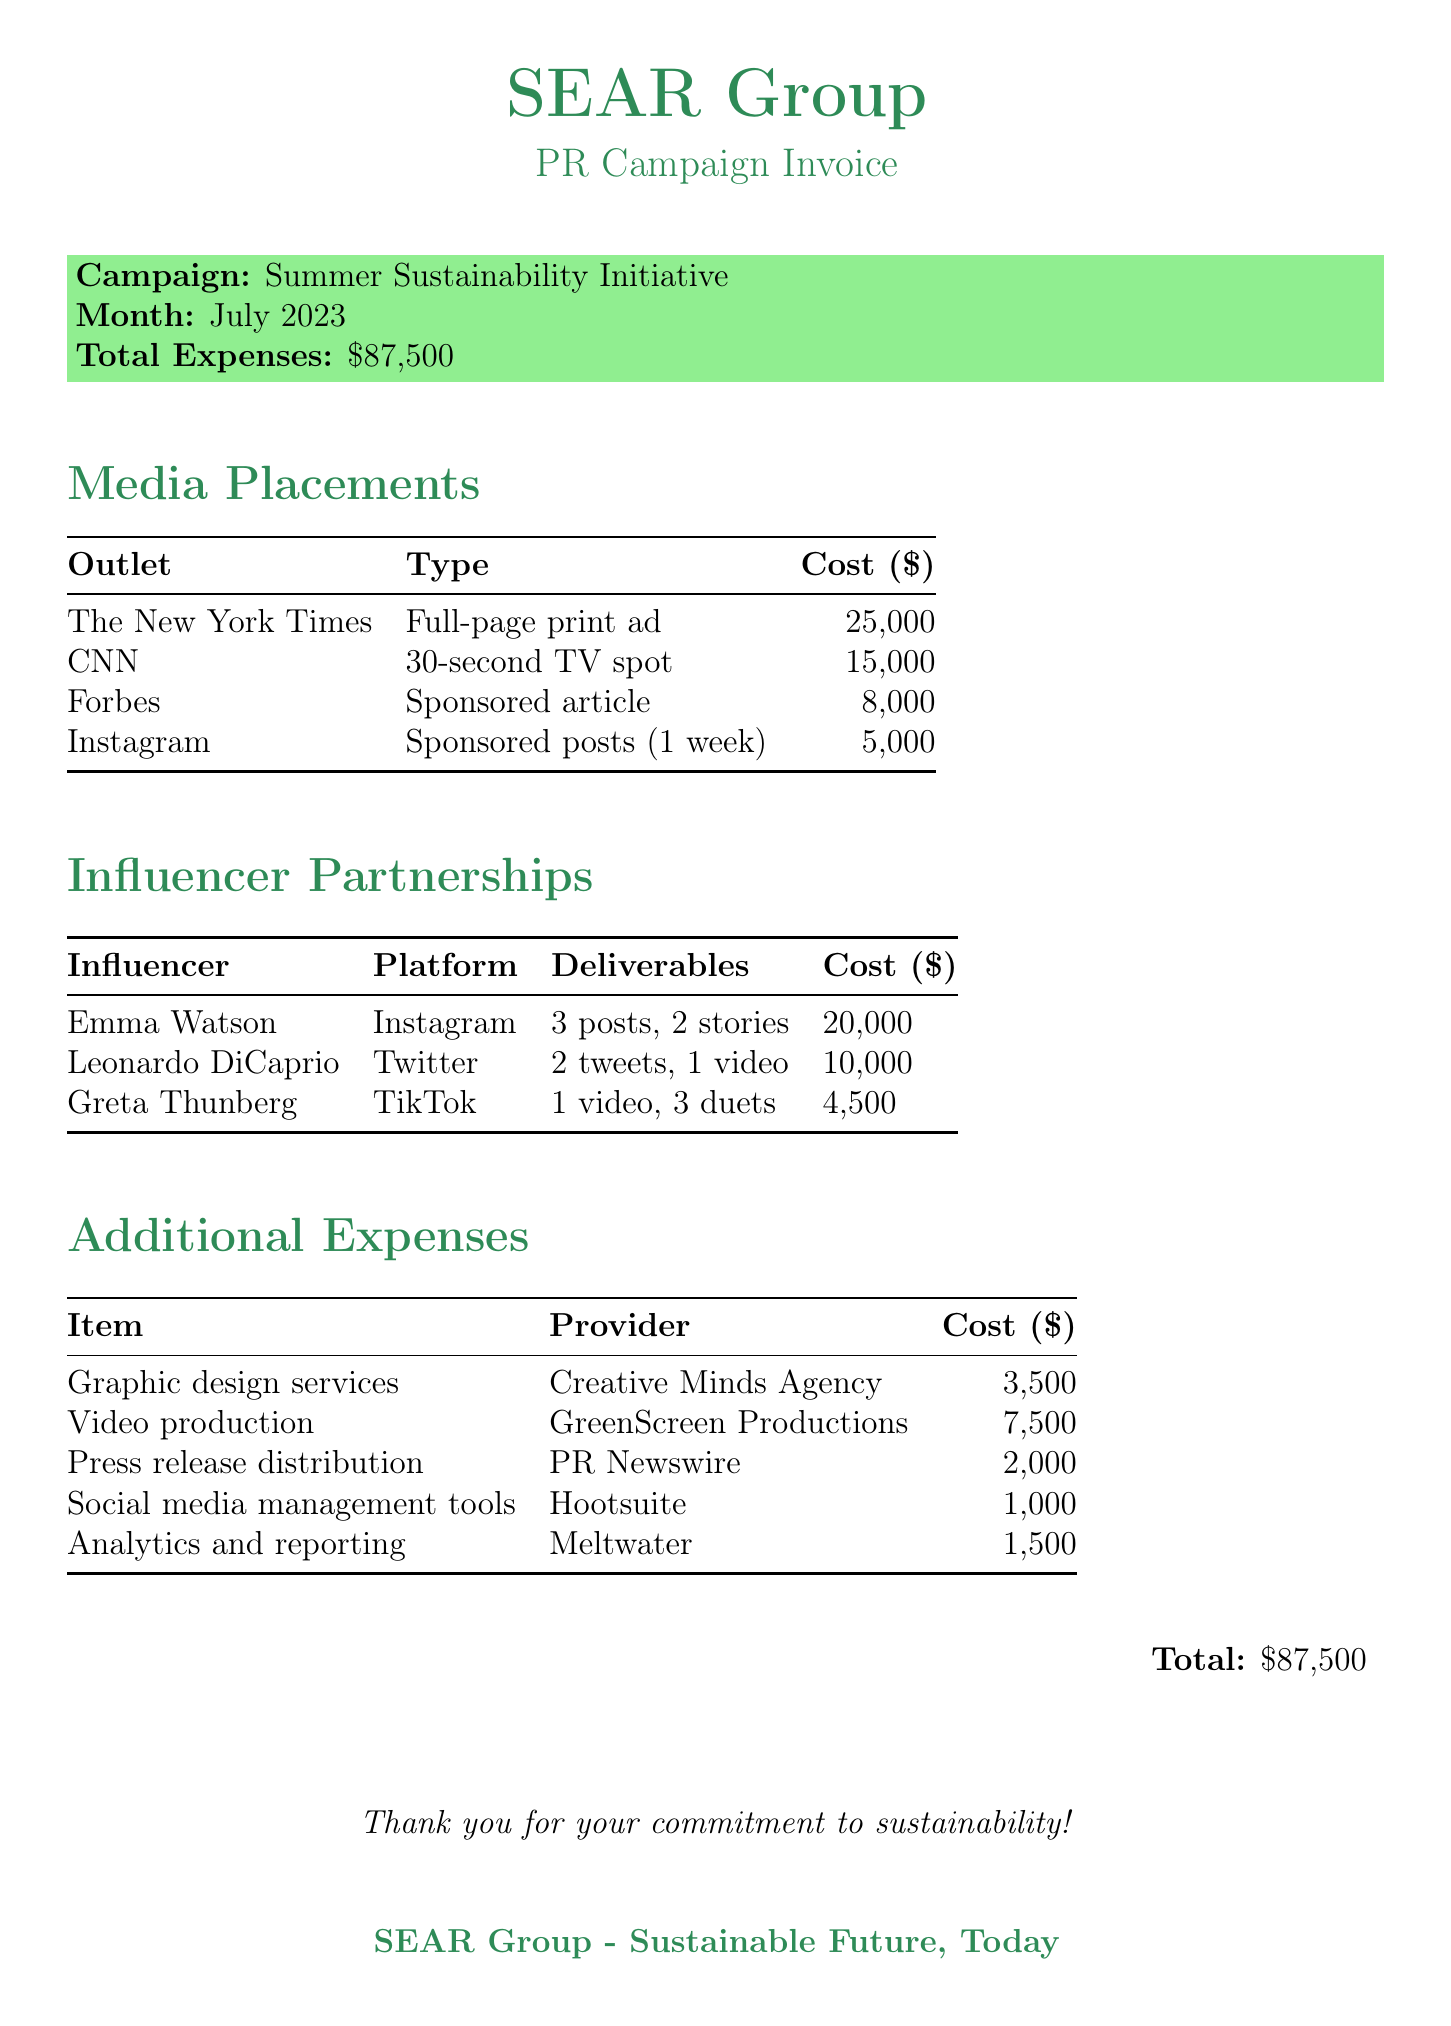What is the campaign name? The campaign name is mentioned prominently at the top of the invoice under the campaign details.
Answer: Summer Sustainability Initiative What is the total expense for July 2023? The total expense is displayed at the bottom of the invoice, summarizing all costs incurred.
Answer: $87,500 How much did SEAR Group spend on influencer partnerships? The total for influencer partnerships can be calculated by adding their individual costs, which are detailed in the table.
Answer: $34,500 Which outlet received the highest payment for media placements? By comparing the costs listed for each media placement, the outlet with the highest value can be identified.
Answer: The New York Times How many deliverables did Emma Watson provide? The deliverables provided by Emma Watson are listed in the influencer partnerships section, which specifies the count.
Answer: 5 What is the cost for press release distribution? The cost for press release distribution is explicitly noted under additional expenses, indicating the amount spent.
Answer: $2,000 Who provided video production services? The provider of video production services is identified in the additional expenses section of the document.
Answer: GreenScreen Productions What type of media placement was used in Forbes? The type of media placement for Forbes is specifically stated in the media placements table of the document.
Answer: Sponsored article Which influencer partnered with SEAR Group on TikTok? The influencer partnering on TikTok is mentioned in the influencer partnerships section of the invoice.
Answer: Greta Thunberg 